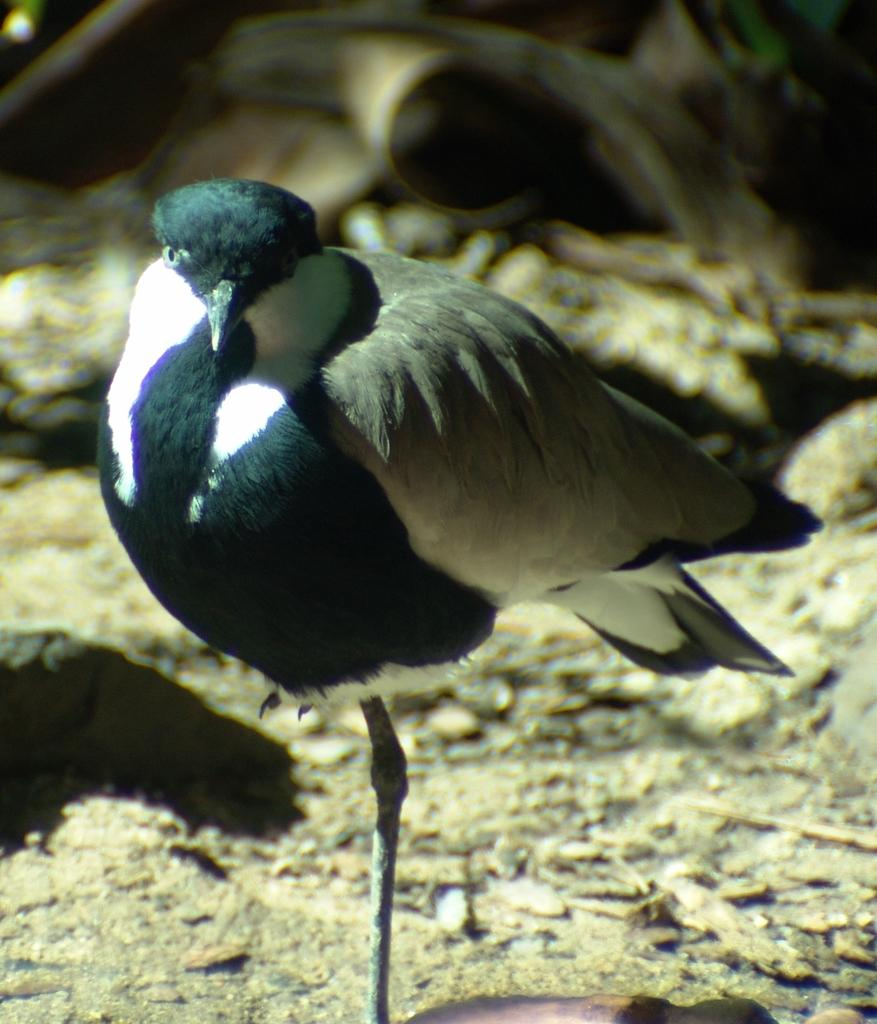What is the main subject of the image? The main subject of the image is a bird. Can you describe the bird's location in the image? The bird is in the middle of the image. What can be observed about the background of the image? The background of the image is blurry. What type of fiction is the bird reading in the image? There is no indication in the image that the bird is reading any fiction, as birds do not read. Can you tell me how the porter is serving the stew in the image? There is no porter or stew present in the image; it features a bird in the middle of the image with a blurry background. 